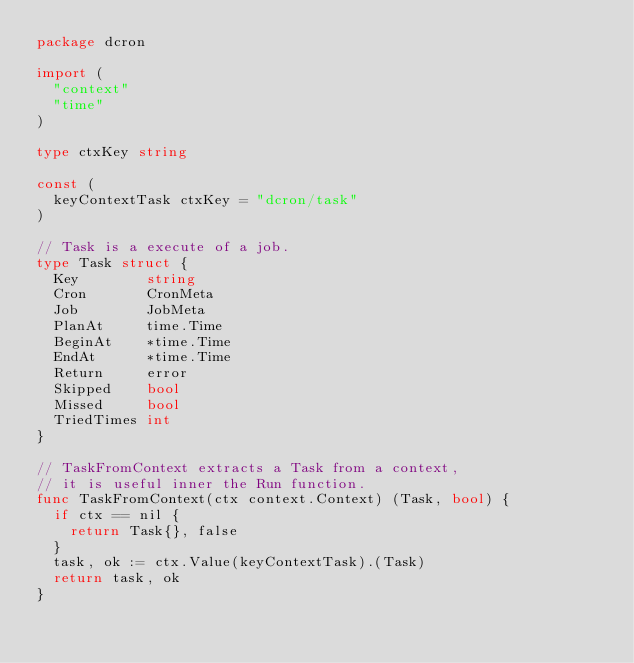Convert code to text. <code><loc_0><loc_0><loc_500><loc_500><_Go_>package dcron

import (
	"context"
	"time"
)

type ctxKey string

const (
	keyContextTask ctxKey = "dcron/task"
)

// Task is a execute of a job.
type Task struct {
	Key        string
	Cron       CronMeta
	Job        JobMeta
	PlanAt     time.Time
	BeginAt    *time.Time
	EndAt      *time.Time
	Return     error
	Skipped    bool
	Missed     bool
	TriedTimes int
}

// TaskFromContext extracts a Task from a context,
// it is useful inner the Run function.
func TaskFromContext(ctx context.Context) (Task, bool) {
	if ctx == nil {
		return Task{}, false
	}
	task, ok := ctx.Value(keyContextTask).(Task)
	return task, ok
}
</code> 